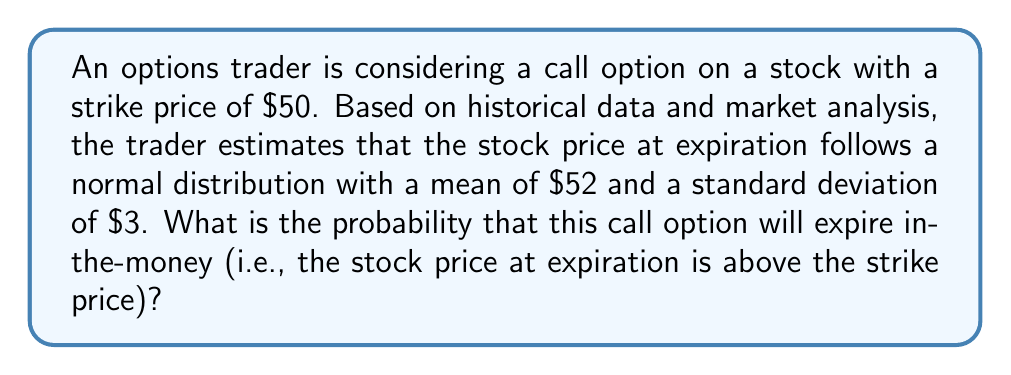Give your solution to this math problem. To solve this problem, we need to use the properties of the normal distribution and calculate the z-score for the strike price.

Step 1: Identify the relevant values
- Strike price: $50
- Mean stock price at expiration: $\mu = $52
- Standard deviation: $\sigma = $3

Step 2: Calculate the z-score for the strike price
The z-score formula is: $z = \frac{x - \mu}{\sigma}$

Where $x$ is the strike price, $\mu$ is the mean, and $\sigma$ is the standard deviation.

$z = \frac{50 - 52}{3} = -\frac{2}{3} \approx -0.6667$

Step 3: Use the standard normal distribution table or a calculator to find the probability
We need to find $P(X > 50)$, which is equivalent to $P(Z > -0.6667)$

Using a standard normal distribution table or calculator, we find:
$P(Z > -0.6667) \approx 0.7475$

Step 4: Interpret the result
The probability that the stock price will be above $50 at expiration is approximately 0.7475 or 74.75%.

Therefore, the probability that the call option will expire in-the-money is about 74.75%.
Answer: $0.7475$ or $74.75\%$ 